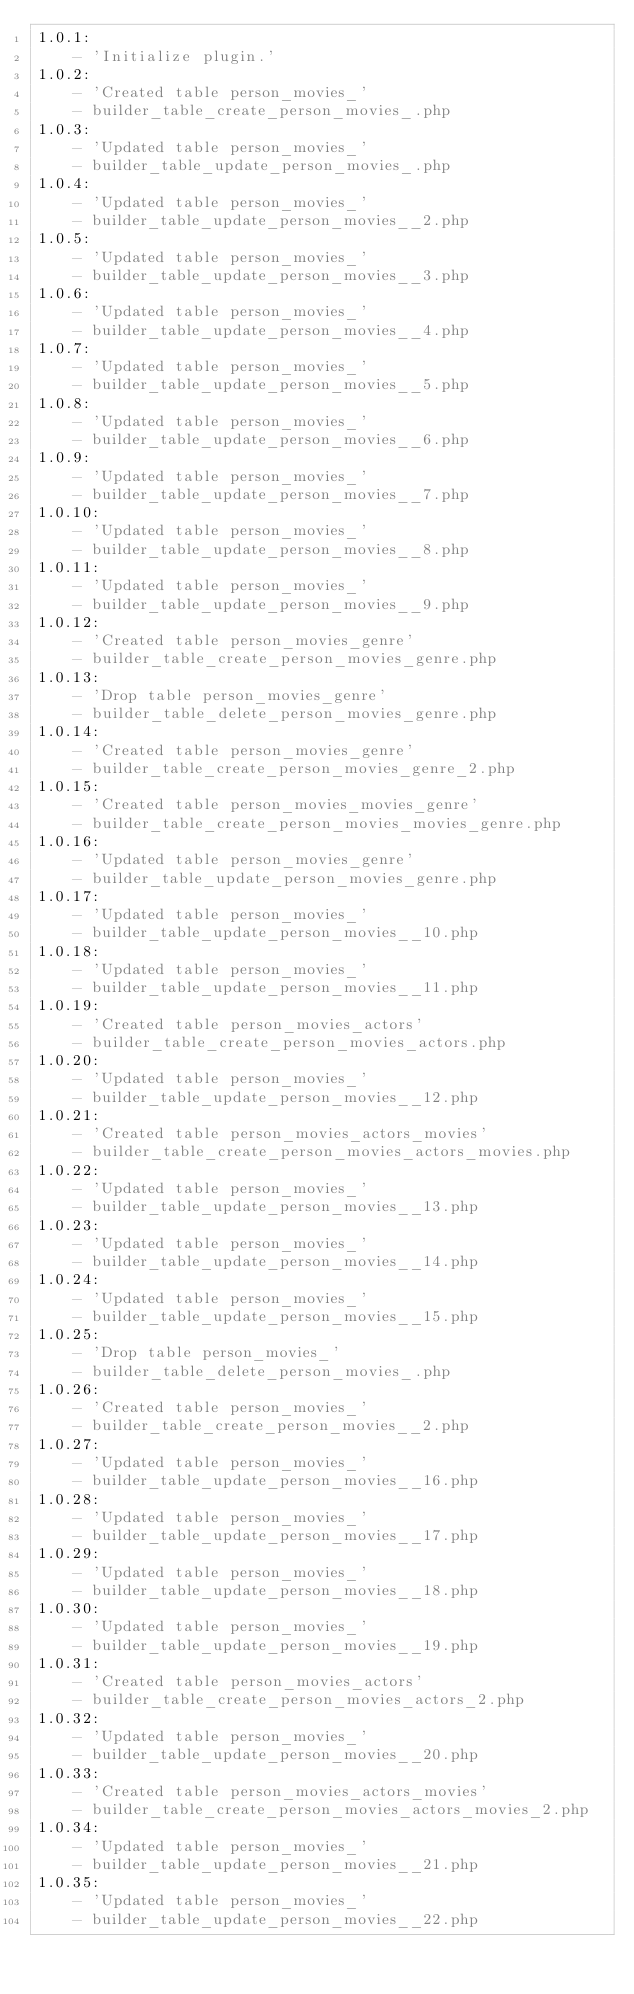<code> <loc_0><loc_0><loc_500><loc_500><_YAML_>1.0.1:
    - 'Initialize plugin.'
1.0.2:
    - 'Created table person_movies_'
    - builder_table_create_person_movies_.php
1.0.3:
    - 'Updated table person_movies_'
    - builder_table_update_person_movies_.php
1.0.4:
    - 'Updated table person_movies_'
    - builder_table_update_person_movies__2.php
1.0.5:
    - 'Updated table person_movies_'
    - builder_table_update_person_movies__3.php
1.0.6:
    - 'Updated table person_movies_'
    - builder_table_update_person_movies__4.php
1.0.7:
    - 'Updated table person_movies_'
    - builder_table_update_person_movies__5.php
1.0.8:
    - 'Updated table person_movies_'
    - builder_table_update_person_movies__6.php
1.0.9:
    - 'Updated table person_movies_'
    - builder_table_update_person_movies__7.php
1.0.10:
    - 'Updated table person_movies_'
    - builder_table_update_person_movies__8.php
1.0.11:
    - 'Updated table person_movies_'
    - builder_table_update_person_movies__9.php
1.0.12:
    - 'Created table person_movies_genre'
    - builder_table_create_person_movies_genre.php
1.0.13:
    - 'Drop table person_movies_genre'
    - builder_table_delete_person_movies_genre.php
1.0.14:
    - 'Created table person_movies_genre'
    - builder_table_create_person_movies_genre_2.php
1.0.15:
    - 'Created table person_movies_movies_genre'
    - builder_table_create_person_movies_movies_genre.php
1.0.16:
    - 'Updated table person_movies_genre'
    - builder_table_update_person_movies_genre.php
1.0.17:
    - 'Updated table person_movies_'
    - builder_table_update_person_movies__10.php
1.0.18:
    - 'Updated table person_movies_'
    - builder_table_update_person_movies__11.php
1.0.19:
    - 'Created table person_movies_actors'
    - builder_table_create_person_movies_actors.php
1.0.20:
    - 'Updated table person_movies_'
    - builder_table_update_person_movies__12.php
1.0.21:
    - 'Created table person_movies_actors_movies'
    - builder_table_create_person_movies_actors_movies.php
1.0.22:
    - 'Updated table person_movies_'
    - builder_table_update_person_movies__13.php
1.0.23:
    - 'Updated table person_movies_'
    - builder_table_update_person_movies__14.php
1.0.24:
    - 'Updated table person_movies_'
    - builder_table_update_person_movies__15.php
1.0.25:
    - 'Drop table person_movies_'
    - builder_table_delete_person_movies_.php
1.0.26:
    - 'Created table person_movies_'
    - builder_table_create_person_movies__2.php
1.0.27:
    - 'Updated table person_movies_'
    - builder_table_update_person_movies__16.php
1.0.28:
    - 'Updated table person_movies_'
    - builder_table_update_person_movies__17.php
1.0.29:
    - 'Updated table person_movies_'
    - builder_table_update_person_movies__18.php
1.0.30:
    - 'Updated table person_movies_'
    - builder_table_update_person_movies__19.php
1.0.31:
    - 'Created table person_movies_actors'
    - builder_table_create_person_movies_actors_2.php
1.0.32:
    - 'Updated table person_movies_'
    - builder_table_update_person_movies__20.php
1.0.33:
    - 'Created table person_movies_actors_movies'
    - builder_table_create_person_movies_actors_movies_2.php
1.0.34:
    - 'Updated table person_movies_'
    - builder_table_update_person_movies__21.php
1.0.35:
    - 'Updated table person_movies_'
    - builder_table_update_person_movies__22.php
</code> 